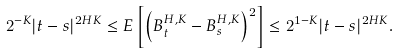<formula> <loc_0><loc_0><loc_500><loc_500>2 ^ { - K } | t - s | ^ { 2 H K } \leq E \left [ \left ( B _ { t } ^ { H , K } - B _ { s } ^ { H , K } \right ) ^ { 2 } \right ] \leq 2 ^ { 1 - K } | t - s | ^ { 2 H K } .</formula> 